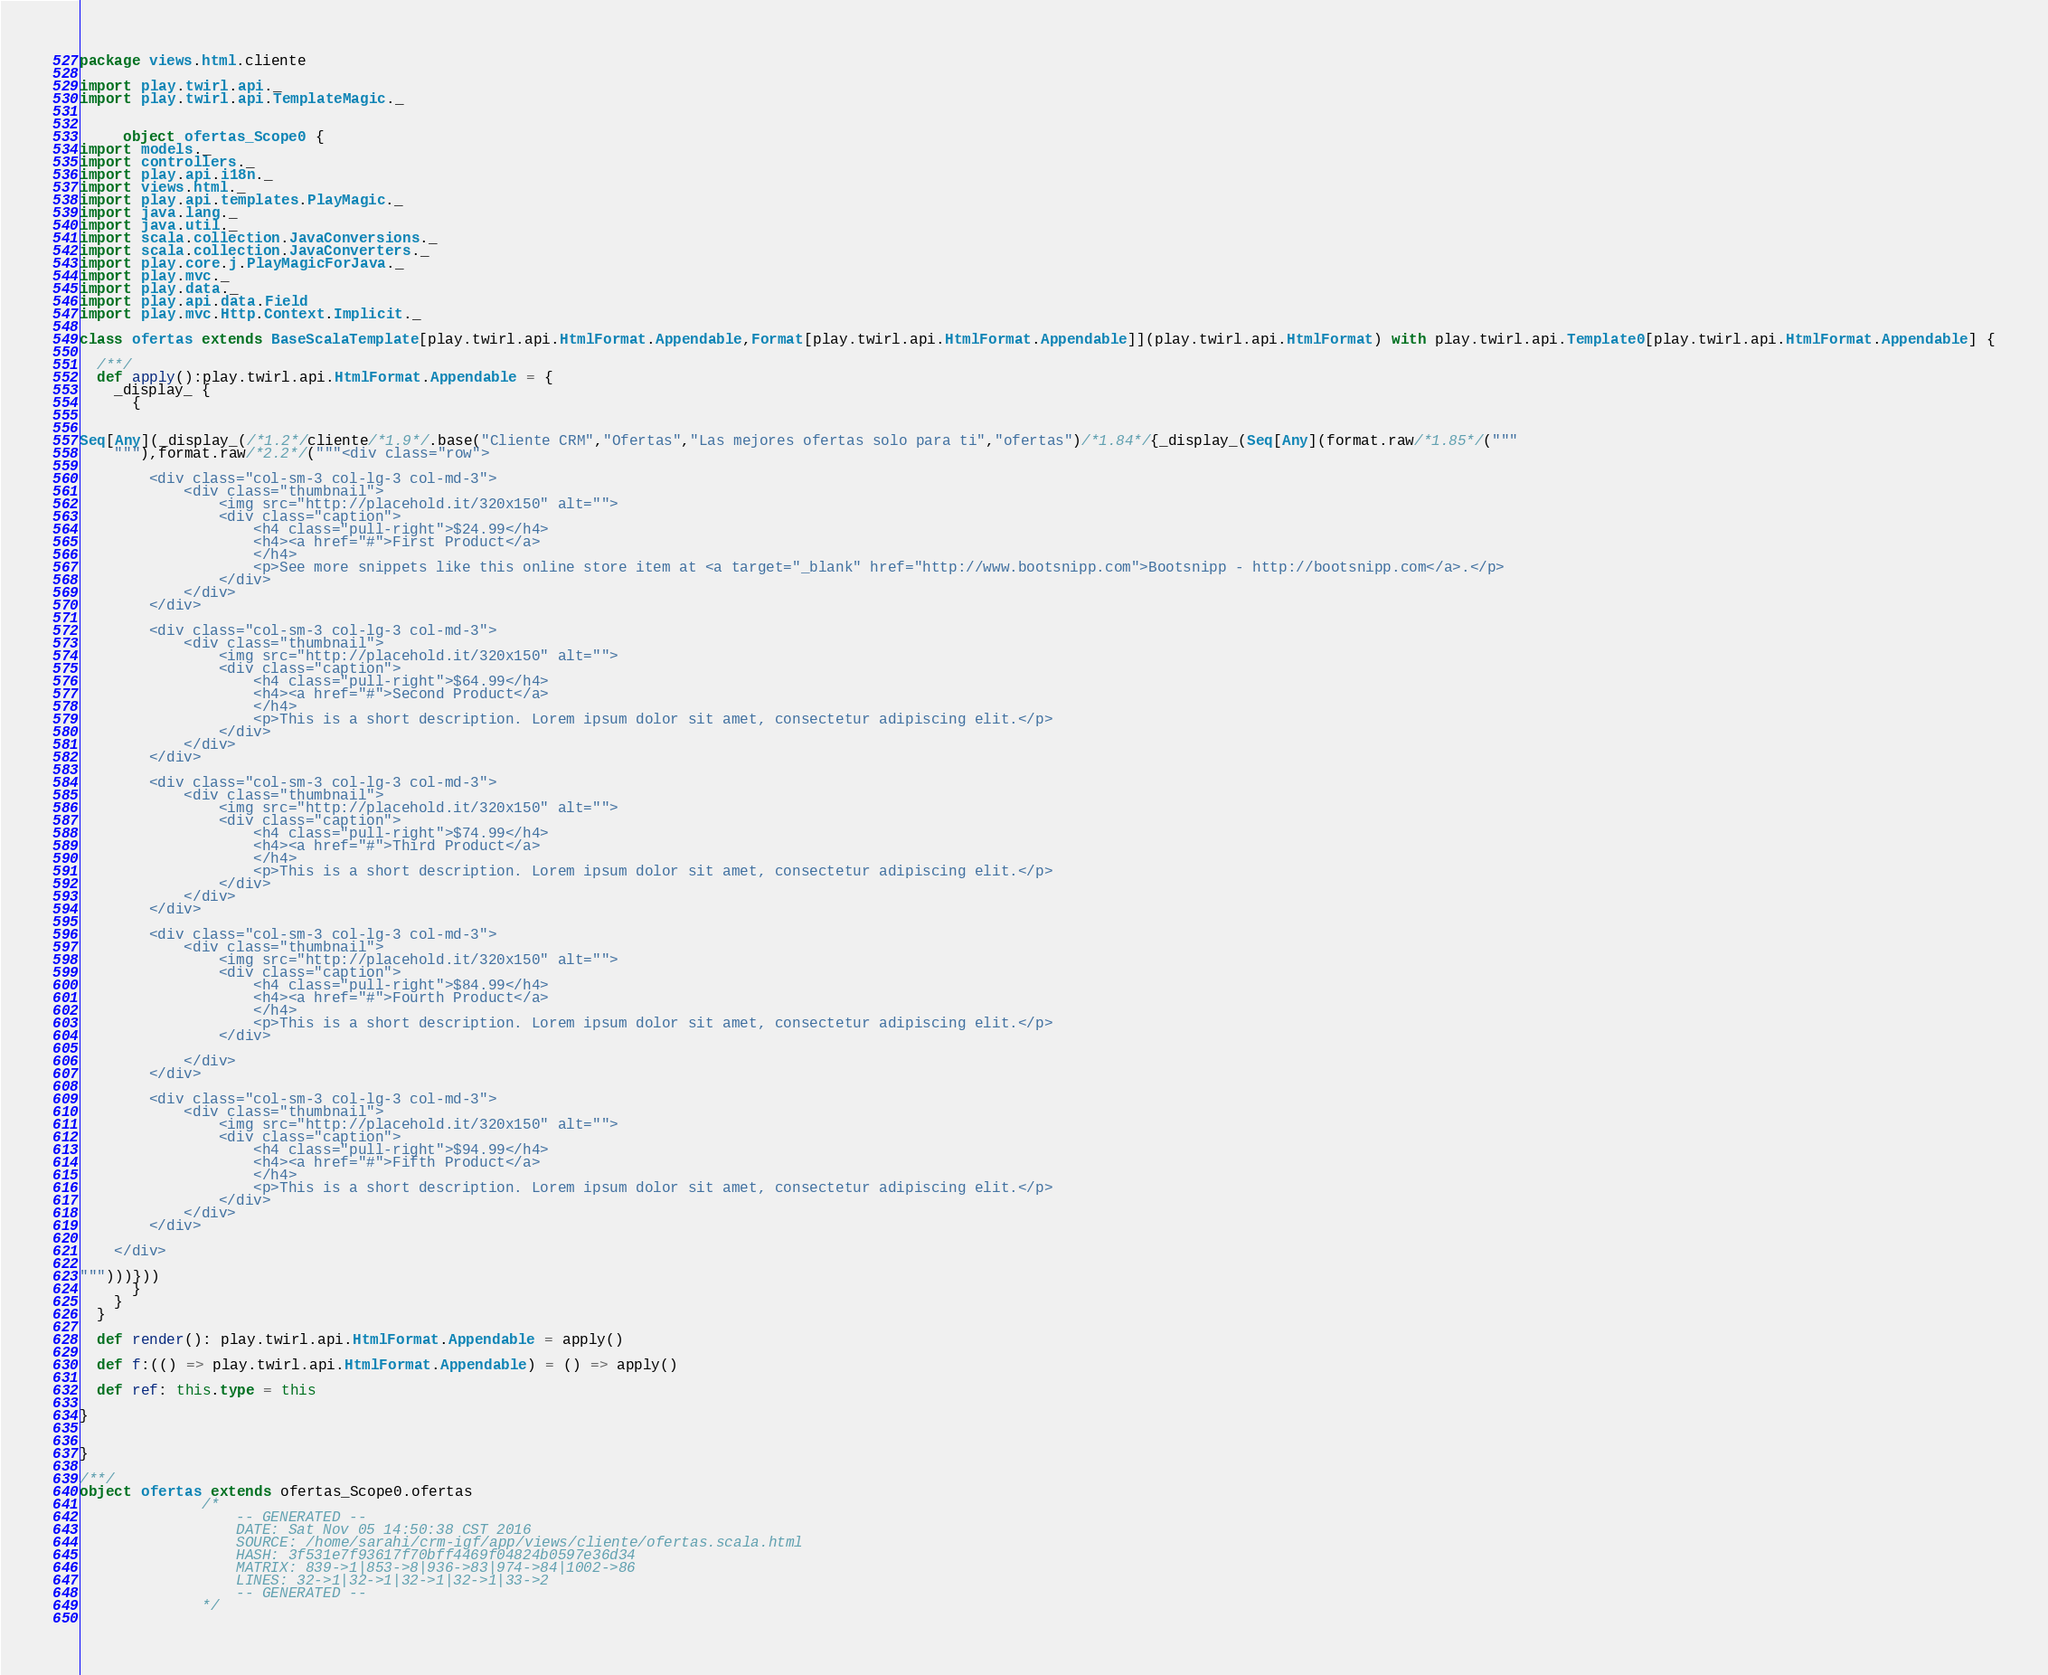Convert code to text. <code><loc_0><loc_0><loc_500><loc_500><_Scala_>
package views.html.cliente

import play.twirl.api._
import play.twirl.api.TemplateMagic._


     object ofertas_Scope0 {
import models._
import controllers._
import play.api.i18n._
import views.html._
import play.api.templates.PlayMagic._
import java.lang._
import java.util._
import scala.collection.JavaConversions._
import scala.collection.JavaConverters._
import play.core.j.PlayMagicForJava._
import play.mvc._
import play.data._
import play.api.data.Field
import play.mvc.Http.Context.Implicit._

class ofertas extends BaseScalaTemplate[play.twirl.api.HtmlFormat.Appendable,Format[play.twirl.api.HtmlFormat.Appendable]](play.twirl.api.HtmlFormat) with play.twirl.api.Template0[play.twirl.api.HtmlFormat.Appendable] {

  /**/
  def apply():play.twirl.api.HtmlFormat.Appendable = {
    _display_ {
      {


Seq[Any](_display_(/*1.2*/cliente/*1.9*/.base("Cliente CRM","Ofertas","Las mejores ofertas solo para ti","ofertas")/*1.84*/{_display_(Seq[Any](format.raw/*1.85*/("""
	"""),format.raw/*2.2*/("""<div class="row">

	    <div class="col-sm-3 col-lg-3 col-md-3">
	        <div class="thumbnail">
	            <img src="http://placehold.it/320x150" alt="">
	            <div class="caption">
	                <h4 class="pull-right">$24.99</h4>
	                <h4><a href="#">First Product</a>
	                </h4>
	                <p>See more snippets like this online store item at <a target="_blank" href="http://www.bootsnipp.com">Bootsnipp - http://bootsnipp.com</a>.</p>
	            </div>
	        </div>
	    </div>

	    <div class="col-sm-3 col-lg-3 col-md-3">
	        <div class="thumbnail">
	            <img src="http://placehold.it/320x150" alt="">
	            <div class="caption">
	                <h4 class="pull-right">$64.99</h4>
	                <h4><a href="#">Second Product</a>
	                </h4>
	                <p>This is a short description. Lorem ipsum dolor sit amet, consectetur adipiscing elit.</p>
	            </div>
	        </div>
	    </div>

	    <div class="col-sm-3 col-lg-3 col-md-3">
	        <div class="thumbnail">
	            <img src="http://placehold.it/320x150" alt="">
	            <div class="caption">
	                <h4 class="pull-right">$74.99</h4>
	                <h4><a href="#">Third Product</a>
	                </h4>
	                <p>This is a short description. Lorem ipsum dolor sit amet, consectetur adipiscing elit.</p>
	            </div>
	        </div>
	    </div>

	    <div class="col-sm-3 col-lg-3 col-md-3">
	        <div class="thumbnail">
	            <img src="http://placehold.it/320x150" alt="">
	            <div class="caption">
	                <h4 class="pull-right">$84.99</h4>
	                <h4><a href="#">Fourth Product</a>
	                </h4>
	                <p>This is a short description. Lorem ipsum dolor sit amet, consectetur adipiscing elit.</p>
	            </div>

	        </div>
	    </div>

	    <div class="col-sm-3 col-lg-3 col-md-3">
	        <div class="thumbnail">
	            <img src="http://placehold.it/320x150" alt="">
	            <div class="caption">
	                <h4 class="pull-right">$94.99</h4>
	                <h4><a href="#">Fifth Product</a>
	                </h4>
	                <p>This is a short description. Lorem ipsum dolor sit amet, consectetur adipiscing elit.</p>
	            </div>
	        </div>
	    </div>

	</div>

""")))}))
      }
    }
  }

  def render(): play.twirl.api.HtmlFormat.Appendable = apply()

  def f:(() => play.twirl.api.HtmlFormat.Appendable) = () => apply()

  def ref: this.type = this

}


}

/**/
object ofertas extends ofertas_Scope0.ofertas
              /*
                  -- GENERATED --
                  DATE: Sat Nov 05 14:50:38 CST 2016
                  SOURCE: /home/sarahi/crm-igf/app/views/cliente/ofertas.scala.html
                  HASH: 3f531e7f93617f70bff4469f04824b0597e36d34
                  MATRIX: 839->1|853->8|936->83|974->84|1002->86
                  LINES: 32->1|32->1|32->1|32->1|33->2
                  -- GENERATED --
              */
          </code> 